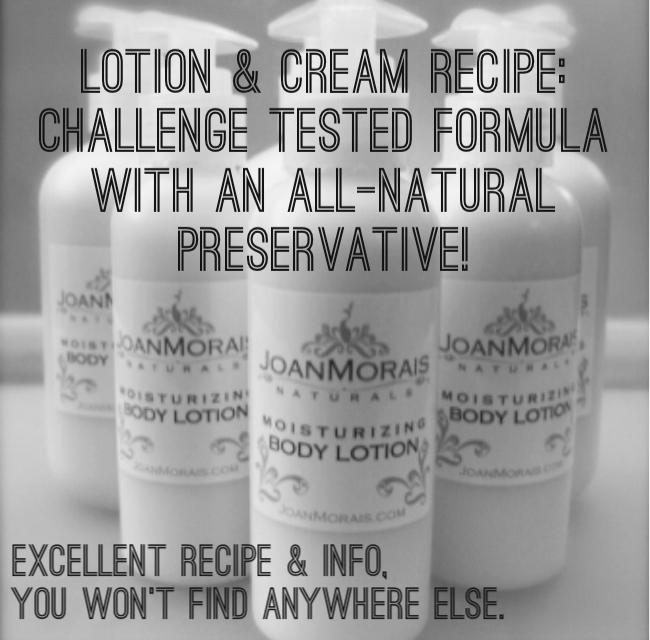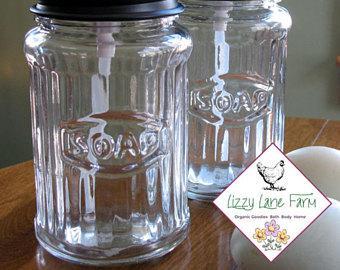The first image is the image on the left, the second image is the image on the right. Considering the images on both sides, is "At least one container is open." valid? Answer yes or no. No. 